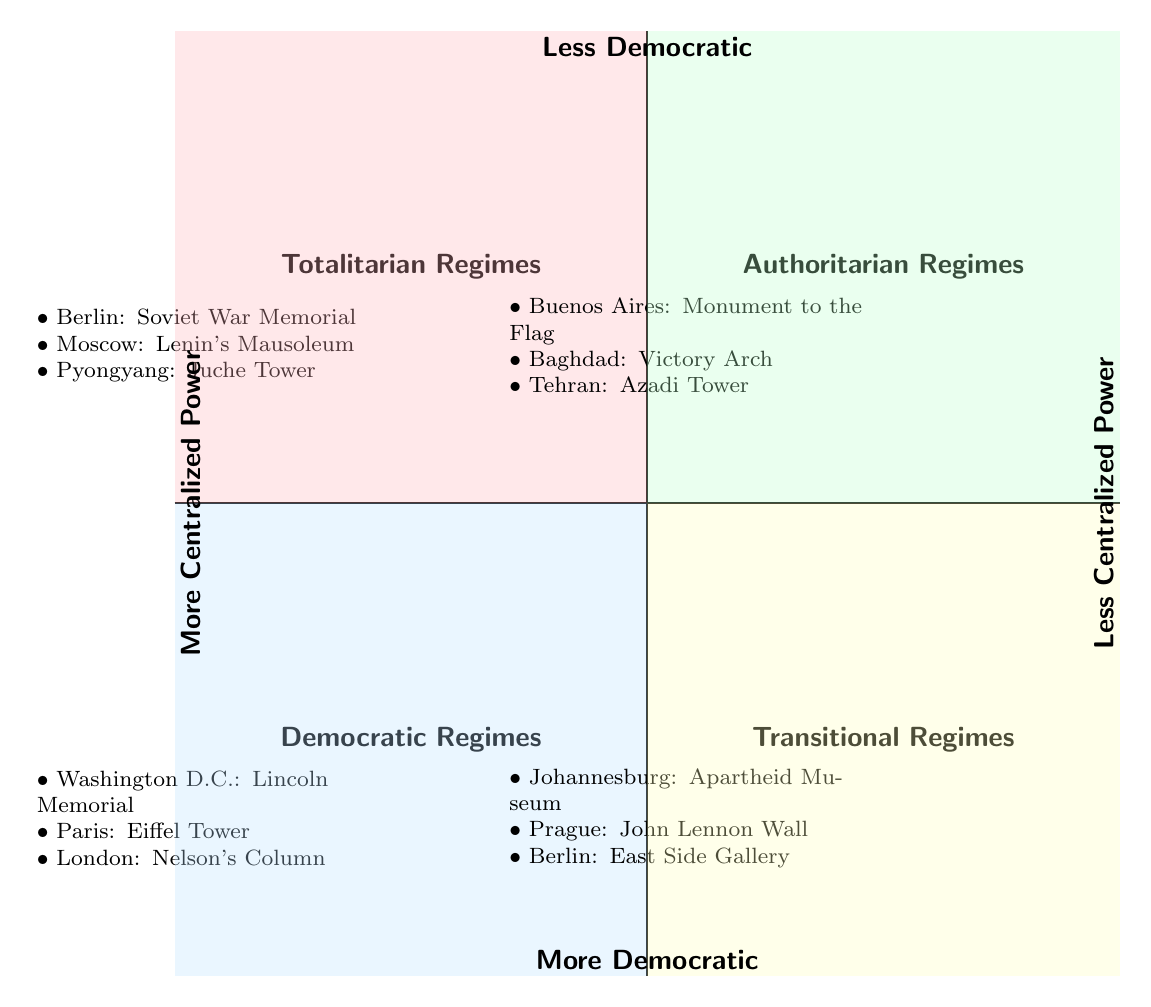What location is associated with the Juche Tower? The Juche Tower is located in Pyongyang, which is listed under Totalitarian Regimes in the diagram.
Answer: Pyongyang How many symbols are listed under Authoritarian Regimes? There are three symbols listed under the Authoritarian Regimes quadrant: Monument to the Flag, Victory Arch, and Azadi Tower, which results in a count of three.
Answer: 3 Which regime's symbols have the most varied time periods? The Transitions Regimes quadrant features symbols with different time periods, such as the Apartheid Museum (2001-Present), John Lennon Wall (1980-Present), and East Side Gallery (1990-Present), indicating variability over time.
Answer: Transitional Regimes What does the Lincoln Memorial symbolize? The Lincoln Memorial is symbolically tied to the Democratic Regimes quadrant, representing democratic values and historical significance in Washington D.C., where it's located.
Answer: Democratic values Which city features both the East Side Gallery and the Soviet War Memorial? Berlin features the East Side Gallery in the Transitional Regimes quadrant and the Soviet War Memorial in the Totalitarian Regimes quadrant, confirming its presence in both categories.
Answer: Berlin What is the time period for the Victory Arch in Baghdad? The time period for the Victory Arch is from 1989 to the present, as stated in the Authoritarian Regimes quadrant, providing a clear temporal context.
Answer: 1989-Present Which quadrant has the symbol with the most historical significance? The symbols in the Democratic Regimes category, such as the Lincoln Memorial and the Eiffel Tower, symbolize historical events and democratic ideals, reflecting a rich historical significance.
Answer: Democratic Regimes Which quadrant has the least centralized power? The quadrant associated with the least centralized power is the Democratic Regimes, showcasing symbols that represent democratic structures and freedoms.
Answer: Democratic Regimes 